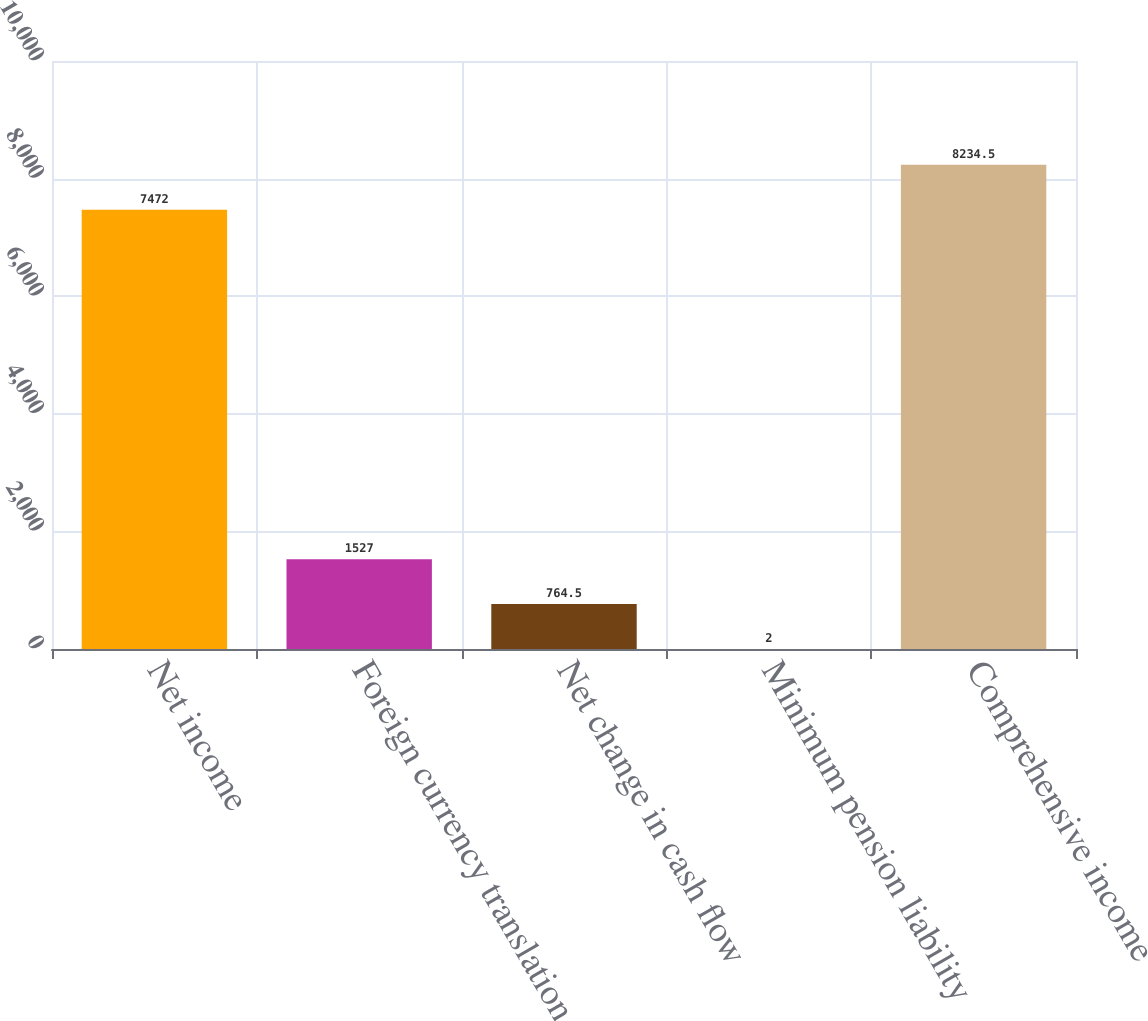Convert chart to OTSL. <chart><loc_0><loc_0><loc_500><loc_500><bar_chart><fcel>Net income<fcel>Foreign currency translation<fcel>Net change in cash flow<fcel>Minimum pension liability<fcel>Comprehensive income<nl><fcel>7472<fcel>1527<fcel>764.5<fcel>2<fcel>8234.5<nl></chart> 